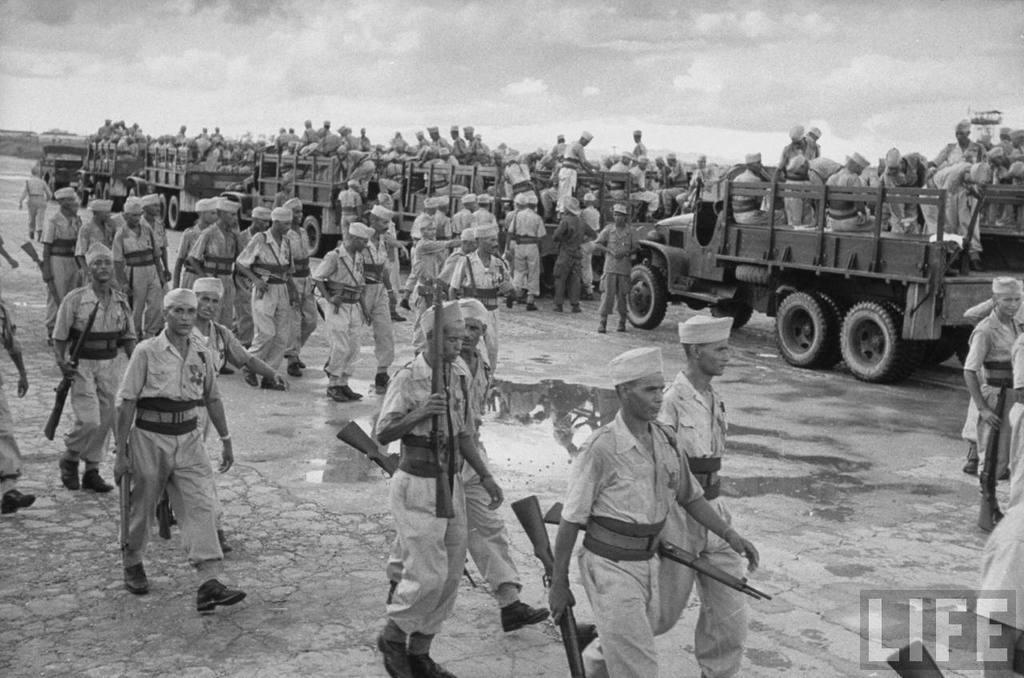Please provide a concise description of this image. This image consists of many persons. In the front, we can see the trucks. All are holding the guns. At the bottom, there is ground. At the top, there are clouds in the sky. 